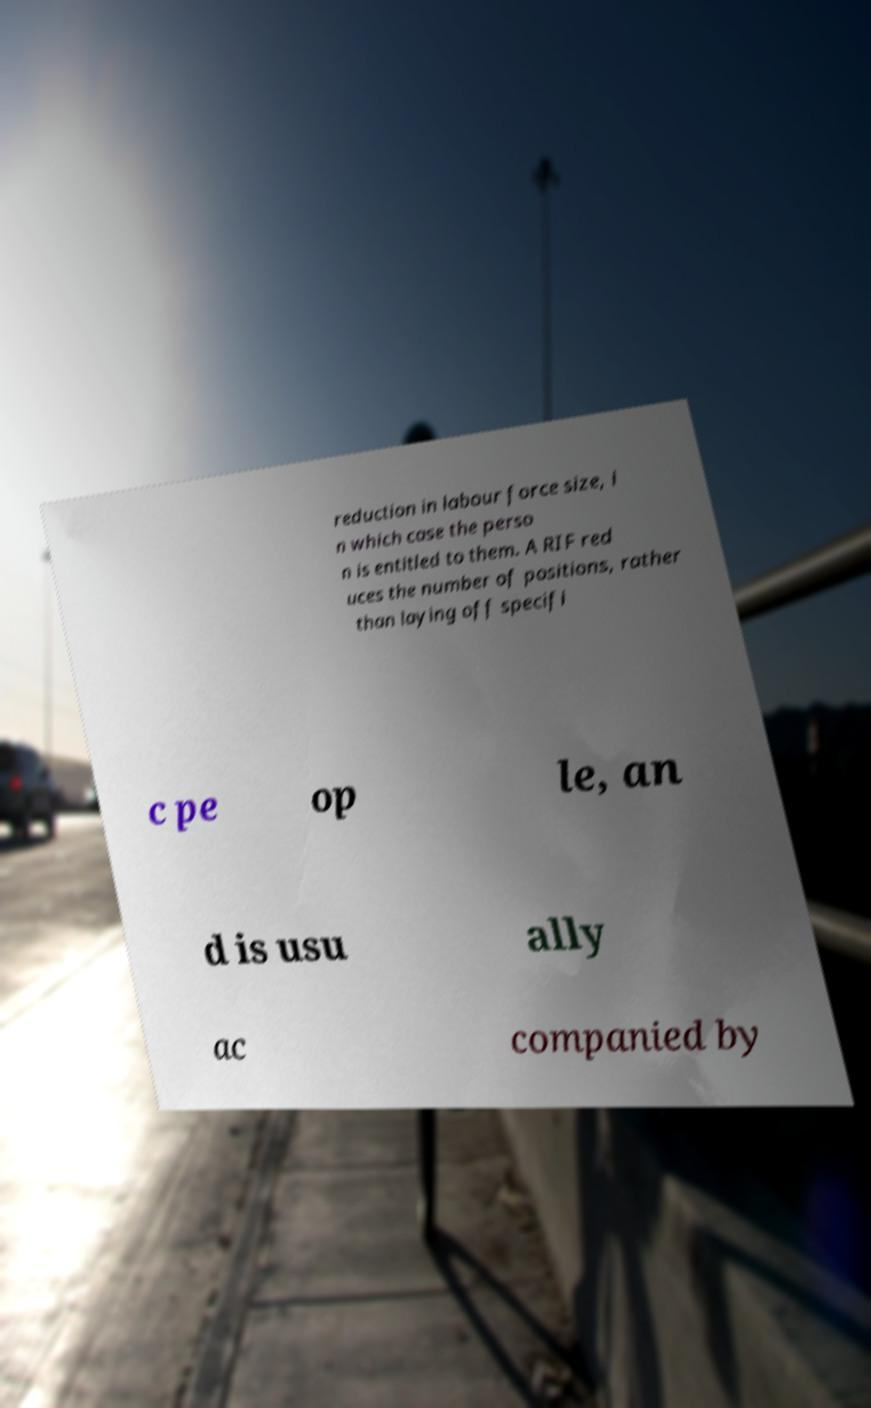Can you read and provide the text displayed in the image?This photo seems to have some interesting text. Can you extract and type it out for me? reduction in labour force size, i n which case the perso n is entitled to them. A RIF red uces the number of positions, rather than laying off specifi c pe op le, an d is usu ally ac companied by 